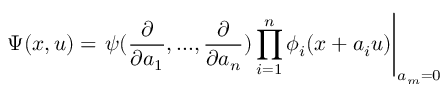Convert formula to latex. <formula><loc_0><loc_0><loc_500><loc_500>\Psi ( x , u ) = \psi ( \frac { \partial } { \partial a _ { 1 } } , \dots , \frac { \partial } { \partial a _ { n } } ) \prod _ { i = 1 } ^ { n } \phi _ { i } ( x + a _ { i } u ) \right | _ { a _ { m } = 0 }</formula> 